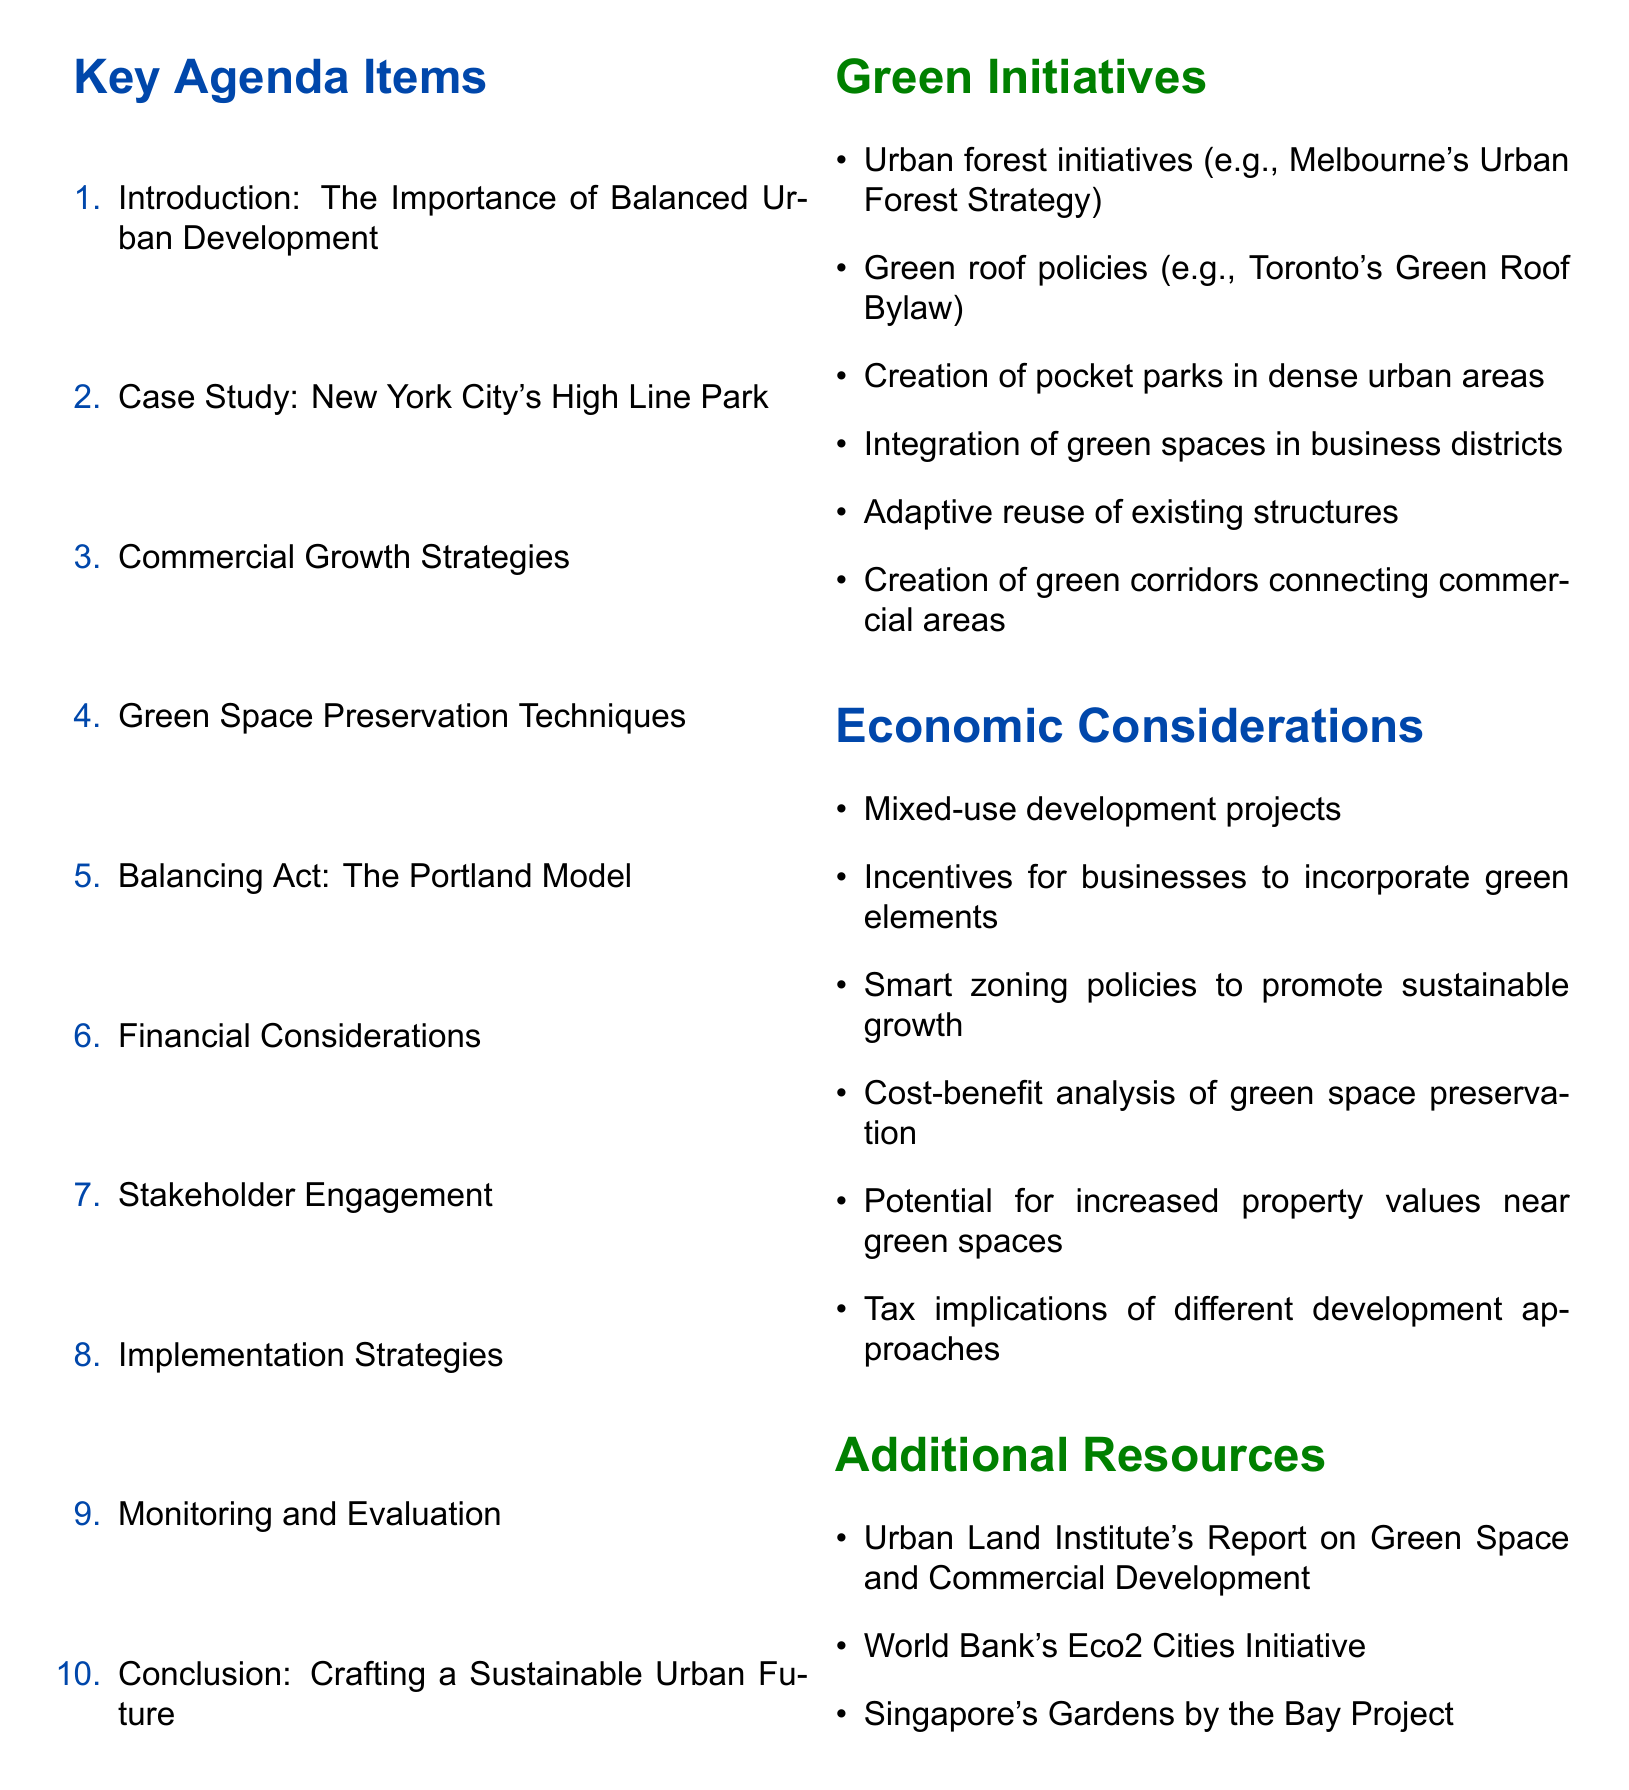What is the title of the document? The title is presented prominently at the beginning of the document, providing a clear overview of its subject matter.
Answer: Urban Development: Balancing Commercial Growth with Green Space Preservation What is one key point under "Introduction"? The introduction outlines the critical discussion points regarding economic growth and environmental issues in urban development.
Answer: Economic growth vs. environmental preservation Which city's park is used as a case study in the agenda? The document includes a specific case study that illustrates successful urban green space integration.
Answer: New York City What type of strategies are discussed in the "Commercial Growth Strategies" section? This section highlights different approaches that could encourage businesses while maintaining green initiatives.
Answer: Mixed-use development projects What are the financial considerations related to green space? This section discusses the economic implications and potential financial benefits of preserving green space.
Answer: Cost-benefit analysis of green space preservation Which city's model is referred to as the "Balancing Act"? This references a successful policy initiative that balances development with environmental considerations.
Answer: Portland How many key agenda items are listed in the document? The document organizes its main discussion points into a structured format, allowing for easy reference.
Answer: Ten What type of organizations are involved in "Stakeholder Engagement"? This reflects the importance of collaboration between different types of entities in planning and development.
Answer: Local business associations What does the conclusion call policymakers to action for? The conclusion emphasizes a forward-looking perspective aiming to encourage specific actions among policymakers.
Answer: Prioritize balanced development 